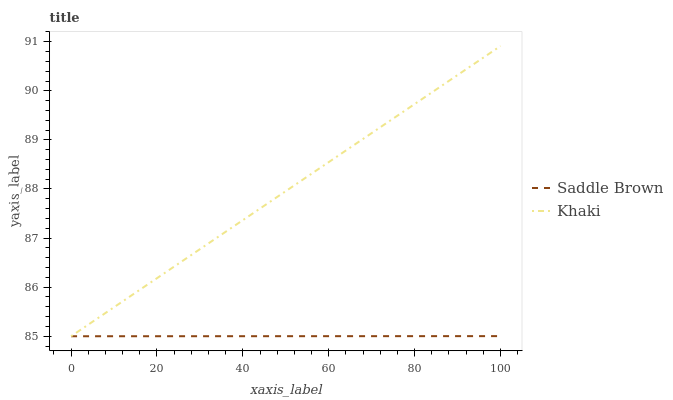Does Saddle Brown have the minimum area under the curve?
Answer yes or no. Yes. Does Khaki have the maximum area under the curve?
Answer yes or no. Yes. Does Saddle Brown have the maximum area under the curve?
Answer yes or no. No. Is Khaki the smoothest?
Answer yes or no. Yes. Is Saddle Brown the roughest?
Answer yes or no. Yes. Is Saddle Brown the smoothest?
Answer yes or no. No. Does Khaki have the lowest value?
Answer yes or no. Yes. Does Khaki have the highest value?
Answer yes or no. Yes. Does Saddle Brown have the highest value?
Answer yes or no. No. Does Saddle Brown intersect Khaki?
Answer yes or no. Yes. Is Saddle Brown less than Khaki?
Answer yes or no. No. Is Saddle Brown greater than Khaki?
Answer yes or no. No. 